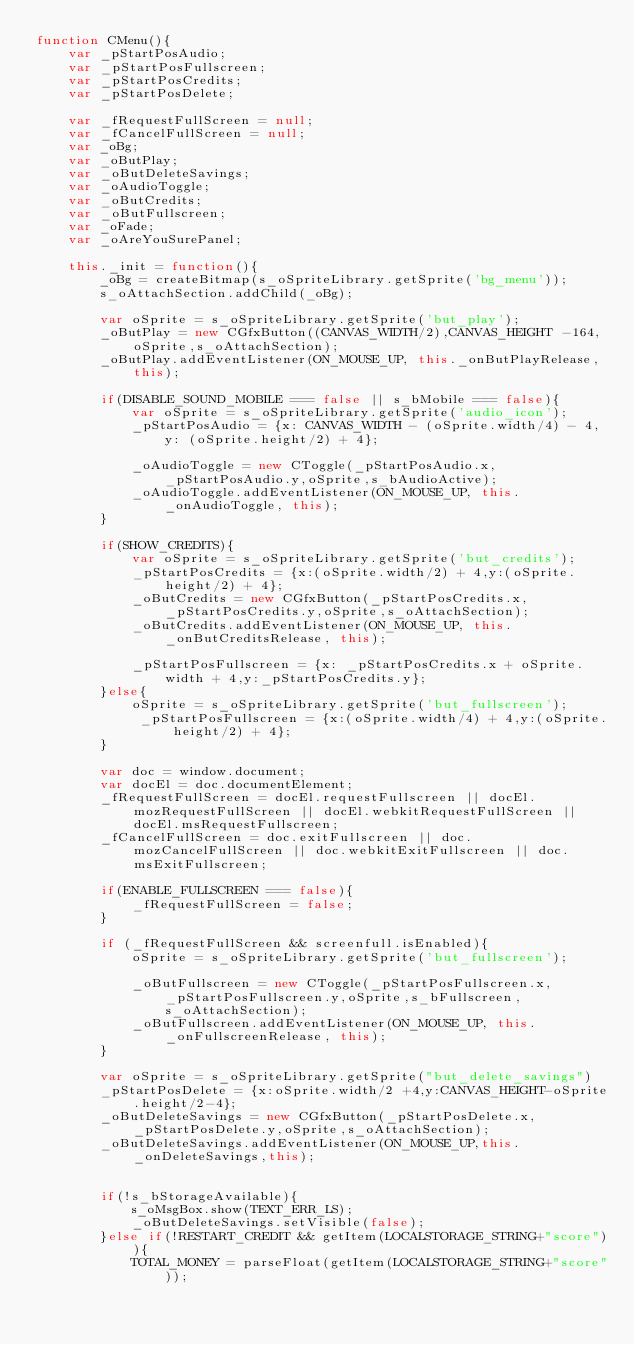Convert code to text. <code><loc_0><loc_0><loc_500><loc_500><_JavaScript_>function CMenu(){
    var _pStartPosAudio;
    var _pStartPosFullscreen;
    var _pStartPosCredits;
    var _pStartPosDelete;
    
    var _fRequestFullScreen = null;
    var _fCancelFullScreen = null;
    var _oBg;
    var _oButPlay;
    var _oButDeleteSavings;
    var _oAudioToggle;
    var _oButCredits;
    var _oButFullscreen;
    var _oFade;
    var _oAreYouSurePanel;
    
    this._init = function(){
        _oBg = createBitmap(s_oSpriteLibrary.getSprite('bg_menu'));
        s_oAttachSection.addChild(_oBg);

        var oSprite = s_oSpriteLibrary.getSprite('but_play');
        _oButPlay = new CGfxButton((CANVAS_WIDTH/2),CANVAS_HEIGHT -164,oSprite,s_oAttachSection);
        _oButPlay.addEventListener(ON_MOUSE_UP, this._onButPlayRelease, this);

        if(DISABLE_SOUND_MOBILE === false || s_bMobile === false){
            var oSprite = s_oSpriteLibrary.getSprite('audio_icon');
            _pStartPosAudio = {x: CANVAS_WIDTH - (oSprite.width/4) - 4, y: (oSprite.height/2) + 4};   
            
            _oAudioToggle = new CToggle(_pStartPosAudio.x,_pStartPosAudio.y,oSprite,s_bAudioActive);
            _oAudioToggle.addEventListener(ON_MOUSE_UP, this._onAudioToggle, this);
        }
        
        if(SHOW_CREDITS){
            var oSprite = s_oSpriteLibrary.getSprite('but_credits');
            _pStartPosCredits = {x:(oSprite.width/2) + 4,y:(oSprite.height/2) + 4};
            _oButCredits = new CGfxButton(_pStartPosCredits.x,_pStartPosCredits.y,oSprite,s_oAttachSection);
            _oButCredits.addEventListener(ON_MOUSE_UP, this._onButCreditsRelease, this);
            
            _pStartPosFullscreen = {x: _pStartPosCredits.x + oSprite.width + 4,y:_pStartPosCredits.y};
        }else{
            oSprite = s_oSpriteLibrary.getSprite('but_fullscreen');
             _pStartPosFullscreen = {x:(oSprite.width/4) + 4,y:(oSprite.height/2) + 4};
        }
        
        var doc = window.document;
        var docEl = doc.documentElement;
        _fRequestFullScreen = docEl.requestFullscreen || docEl.mozRequestFullScreen || docEl.webkitRequestFullScreen || docEl.msRequestFullscreen;
        _fCancelFullScreen = doc.exitFullscreen || doc.mozCancelFullScreen || doc.webkitExitFullscreen || doc.msExitFullscreen;
        
        if(ENABLE_FULLSCREEN === false){
            _fRequestFullScreen = false;
        }
        
        if (_fRequestFullScreen && screenfull.isEnabled){
            oSprite = s_oSpriteLibrary.getSprite('but_fullscreen');

            _oButFullscreen = new CToggle(_pStartPosFullscreen.x,_pStartPosFullscreen.y,oSprite,s_bFullscreen,s_oAttachSection);
            _oButFullscreen.addEventListener(ON_MOUSE_UP, this._onFullscreenRelease, this);
        }
        
        var oSprite = s_oSpriteLibrary.getSprite("but_delete_savings")
        _pStartPosDelete = {x:oSprite.width/2 +4,y:CANVAS_HEIGHT-oSprite.height/2-4};
        _oButDeleteSavings = new CGfxButton(_pStartPosDelete.x,_pStartPosDelete.y,oSprite,s_oAttachSection);
        _oButDeleteSavings.addEventListener(ON_MOUSE_UP,this._onDeleteSavings,this);


        if(!s_bStorageAvailable){
            s_oMsgBox.show(TEXT_ERR_LS);
            _oButDeleteSavings.setVisible(false);
        }else if(!RESTART_CREDIT && getItem(LOCALSTORAGE_STRING+"score")){
            TOTAL_MONEY = parseFloat(getItem(LOCALSTORAGE_STRING+"score"));</code> 